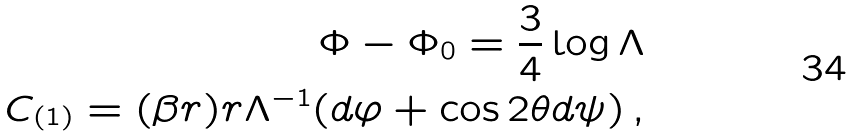Convert formula to latex. <formula><loc_0><loc_0><loc_500><loc_500>\Phi - \Phi _ { 0 } = \frac { 3 } { 4 } \log \Lambda \\ C _ { ( 1 ) } = ( \beta r ) r \Lambda ^ { - 1 } ( d \varphi + \cos 2 \theta d \psi ) \, ,</formula> 